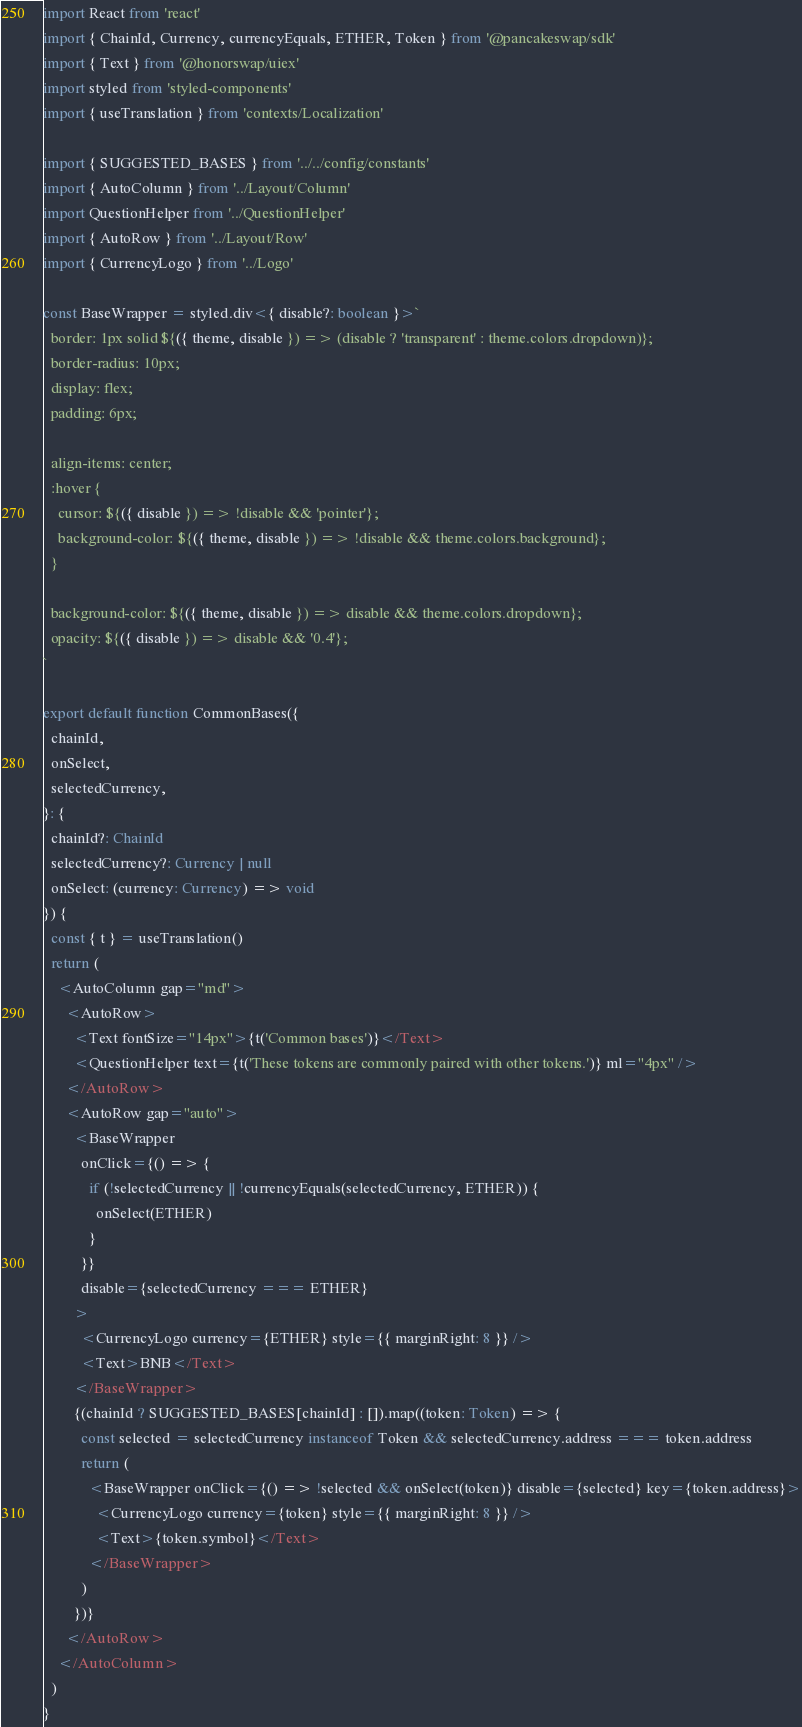<code> <loc_0><loc_0><loc_500><loc_500><_TypeScript_>import React from 'react'
import { ChainId, Currency, currencyEquals, ETHER, Token } from '@pancakeswap/sdk'
import { Text } from '@honorswap/uiex'
import styled from 'styled-components'
import { useTranslation } from 'contexts/Localization'

import { SUGGESTED_BASES } from '../../config/constants'
import { AutoColumn } from '../Layout/Column'
import QuestionHelper from '../QuestionHelper'
import { AutoRow } from '../Layout/Row'
import { CurrencyLogo } from '../Logo'

const BaseWrapper = styled.div<{ disable?: boolean }>`
  border: 1px solid ${({ theme, disable }) => (disable ? 'transparent' : theme.colors.dropdown)};
  border-radius: 10px;
  display: flex;
  padding: 6px;

  align-items: center;
  :hover {
    cursor: ${({ disable }) => !disable && 'pointer'};
    background-color: ${({ theme, disable }) => !disable && theme.colors.background};
  }

  background-color: ${({ theme, disable }) => disable && theme.colors.dropdown};
  opacity: ${({ disable }) => disable && '0.4'};
`

export default function CommonBases({
  chainId,
  onSelect,
  selectedCurrency,
}: {
  chainId?: ChainId
  selectedCurrency?: Currency | null
  onSelect: (currency: Currency) => void
}) {
  const { t } = useTranslation()
  return (
    <AutoColumn gap="md">
      <AutoRow>
        <Text fontSize="14px">{t('Common bases')}</Text>
        <QuestionHelper text={t('These tokens are commonly paired with other tokens.')} ml="4px" />
      </AutoRow>
      <AutoRow gap="auto">
        <BaseWrapper
          onClick={() => {
            if (!selectedCurrency || !currencyEquals(selectedCurrency, ETHER)) {
              onSelect(ETHER)
            }
          }}
          disable={selectedCurrency === ETHER}
        >
          <CurrencyLogo currency={ETHER} style={{ marginRight: 8 }} />
          <Text>BNB</Text>
        </BaseWrapper>
        {(chainId ? SUGGESTED_BASES[chainId] : []).map((token: Token) => {
          const selected = selectedCurrency instanceof Token && selectedCurrency.address === token.address
          return (
            <BaseWrapper onClick={() => !selected && onSelect(token)} disable={selected} key={token.address}>
              <CurrencyLogo currency={token} style={{ marginRight: 8 }} />
              <Text>{token.symbol}</Text>
            </BaseWrapper>
          )
        })}
      </AutoRow>
    </AutoColumn>
  )
}
</code> 